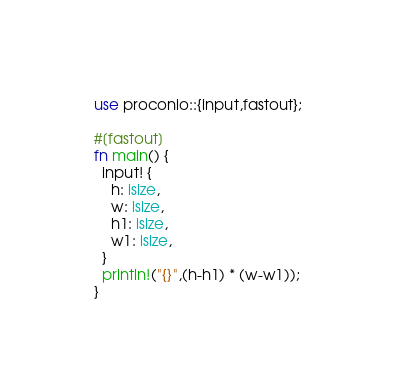Convert code to text. <code><loc_0><loc_0><loc_500><loc_500><_Rust_>use proconio::{input,fastout};

#[fastout]
fn main() {
  input! {
    h: isize,
    w: isize,
    h1: isize,
    w1: isize,
  }
  println!("{}",(h-h1) * (w-w1));
}</code> 